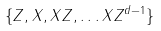<formula> <loc_0><loc_0><loc_500><loc_500>\{ Z , X , X Z , \dots X Z ^ { d - 1 } \}</formula> 